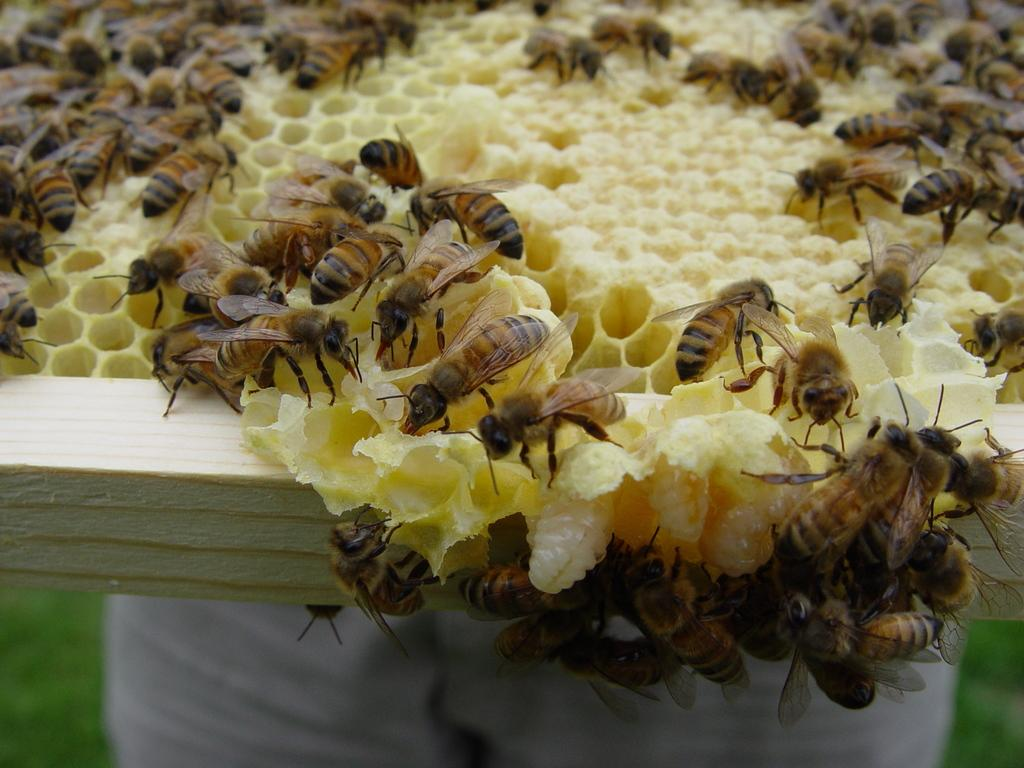What insects can be seen in the image? There are honey bees in the image. Where are the honey bees located? The honey bees are on a honeycomb. What else can be seen in the image besides the honey bees? There are other objects in the image. Are there any snakes visible on the island in the image? There is no island or snakes present in the image; it features honey bees on a honeycomb. 